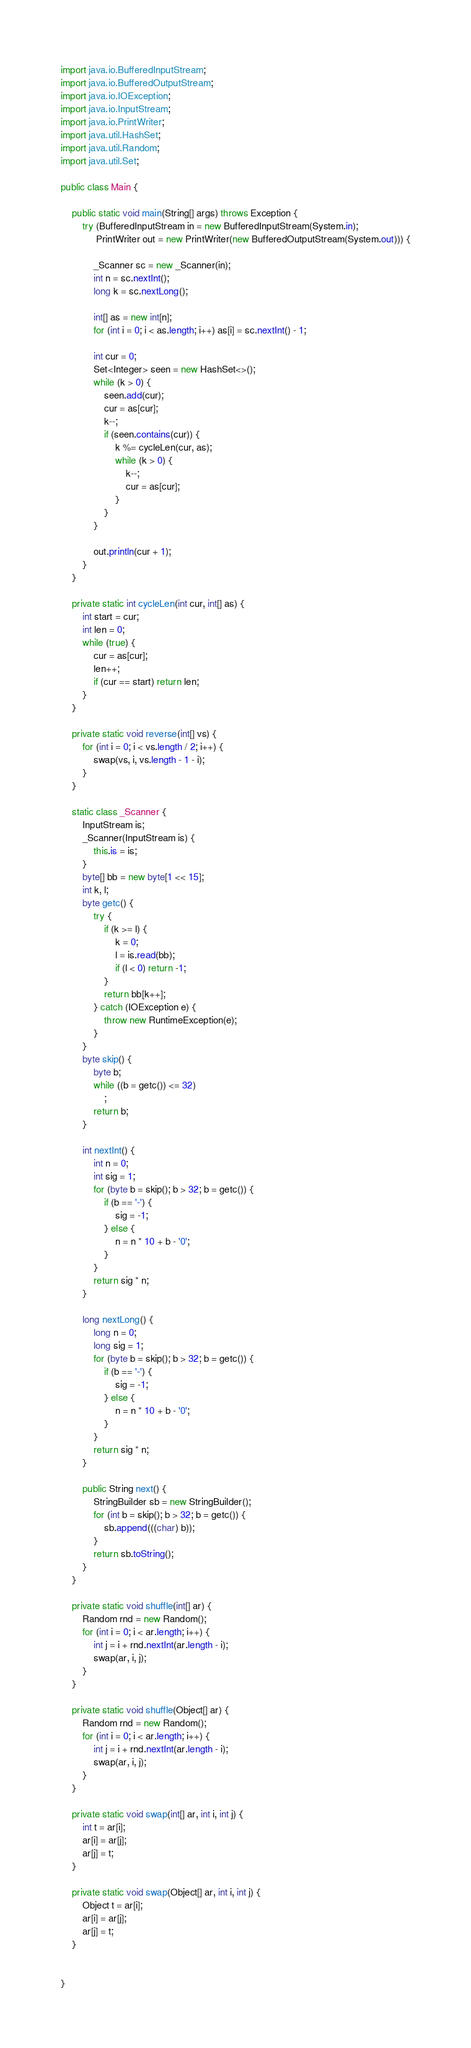<code> <loc_0><loc_0><loc_500><loc_500><_Java_>import java.io.BufferedInputStream;
import java.io.BufferedOutputStream;
import java.io.IOException;
import java.io.InputStream;
import java.io.PrintWriter;
import java.util.HashSet;
import java.util.Random;
import java.util.Set;

public class Main {

    public static void main(String[] args) throws Exception {
        try (BufferedInputStream in = new BufferedInputStream(System.in);
             PrintWriter out = new PrintWriter(new BufferedOutputStream(System.out))) {

            _Scanner sc = new _Scanner(in);
            int n = sc.nextInt();
            long k = sc.nextLong();

            int[] as = new int[n];
            for (int i = 0; i < as.length; i++) as[i] = sc.nextInt() - 1;

            int cur = 0;
            Set<Integer> seen = new HashSet<>();
            while (k > 0) {
                seen.add(cur);
                cur = as[cur];
                k--;
                if (seen.contains(cur)) {
                    k %= cycleLen(cur, as);
                    while (k > 0) {
                        k--;
                        cur = as[cur];
                    }
                }
            }

            out.println(cur + 1);
        }
    }

    private static int cycleLen(int cur, int[] as) {
        int start = cur;
        int len = 0;
        while (true) {
            cur = as[cur];
            len++;
            if (cur == start) return len;
        }
    }

    private static void reverse(int[] vs) {
        for (int i = 0; i < vs.length / 2; i++) {
            swap(vs, i, vs.length - 1 - i);
        }
    }

    static class _Scanner {
        InputStream is;
        _Scanner(InputStream is) {
            this.is = is;
        }
        byte[] bb = new byte[1 << 15];
        int k, l;
        byte getc() {
            try {
                if (k >= l) {
                    k = 0;
                    l = is.read(bb);
                    if (l < 0) return -1;
                }
                return bb[k++];
            } catch (IOException e) {
                throw new RuntimeException(e);
            }
        }
        byte skip() {
            byte b;
            while ((b = getc()) <= 32)
                ;
            return b;
        }

        int nextInt() {
            int n = 0;
            int sig = 1;
            for (byte b = skip(); b > 32; b = getc()) {
                if (b == '-') {
                    sig = -1;
                } else {
                    n = n * 10 + b - '0';
                }
            }
            return sig * n;
        }

        long nextLong() {
            long n = 0;
            long sig = 1;
            for (byte b = skip(); b > 32; b = getc()) {
                if (b == '-') {
                    sig = -1;
                } else {
                    n = n * 10 + b - '0';
                }
            }
            return sig * n;
        }

        public String next() {
            StringBuilder sb = new StringBuilder();
            for (int b = skip(); b > 32; b = getc()) {
                sb.append(((char) b));
            }
            return sb.toString();
        }
    }

    private static void shuffle(int[] ar) {
        Random rnd = new Random();
        for (int i = 0; i < ar.length; i++) {
            int j = i + rnd.nextInt(ar.length - i);
            swap(ar, i, j);
        }
    }

    private static void shuffle(Object[] ar) {
        Random rnd = new Random();
        for (int i = 0; i < ar.length; i++) {
            int j = i + rnd.nextInt(ar.length - i);
            swap(ar, i, j);
        }
    }

    private static void swap(int[] ar, int i, int j) {
        int t = ar[i];
        ar[i] = ar[j];
        ar[j] = t;
    }

    private static void swap(Object[] ar, int i, int j) {
        Object t = ar[i];
        ar[i] = ar[j];
        ar[j] = t;
    }


}
</code> 